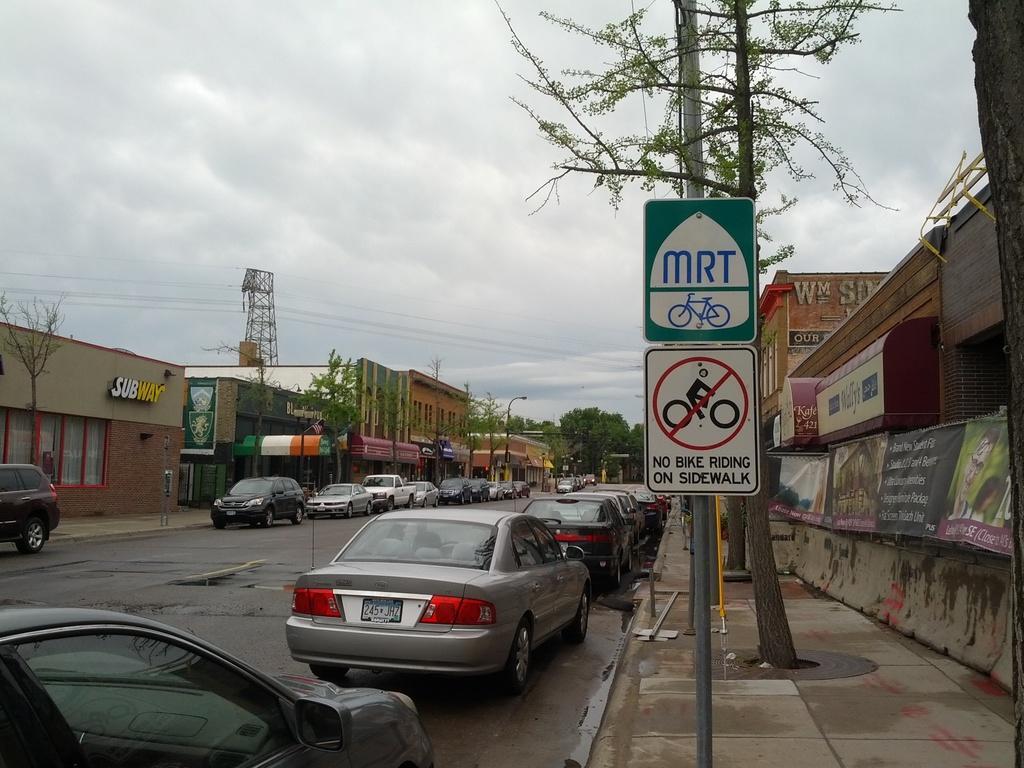How would you summarize this image in a sentence or two? This is an outside view in this image there are a group of cars on the road, and on the right side and left right there are some buildings, boards, poles, lights and some trees. At the bottom there is a road and footpath, and in the background there is a tower and some wires and at the top of the image there is sky. 